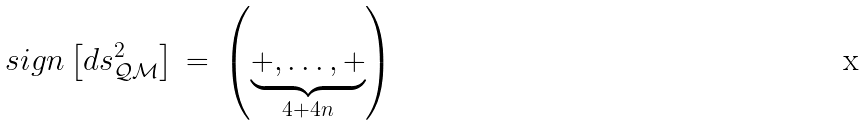Convert formula to latex. <formula><loc_0><loc_0><loc_500><loc_500>s i g n \left [ d s ^ { 2 } _ { \mathcal { Q M } } \right ] \, = \, \left ( \underbrace { + , \dots , + } _ { 4 + 4 n } \right )</formula> 